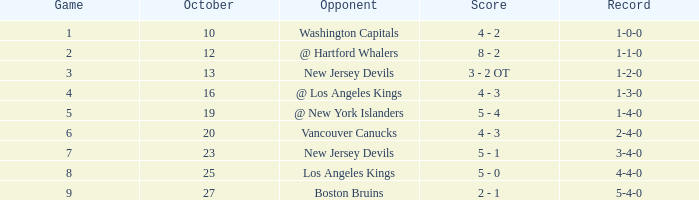What was the average outcome of a game with a 4-4-0 record? 8.0. 